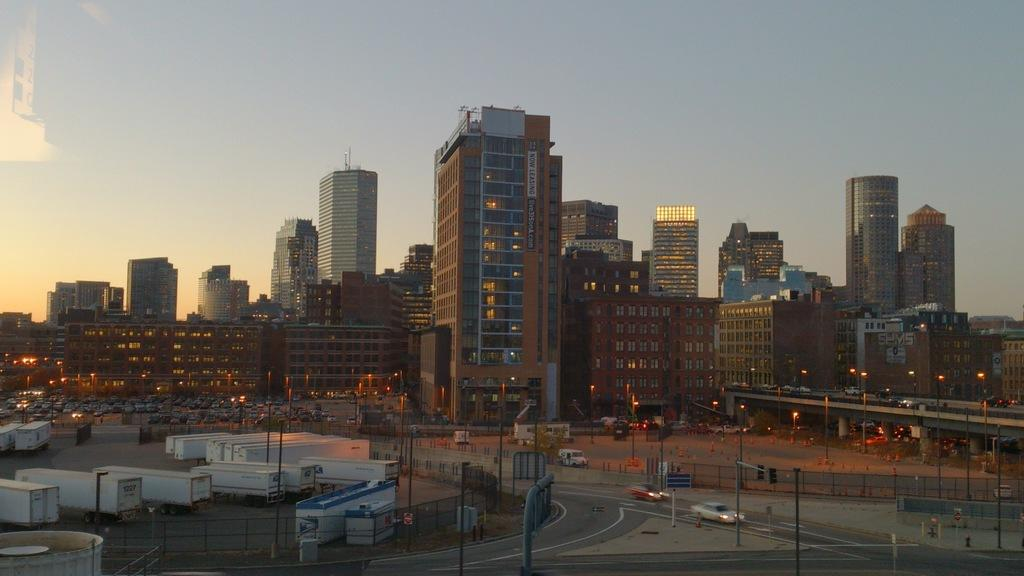What is the main subject of the image? The main subject of the image is many vehicles. Are there any structures or objects surrounding the vehicles? Yes, there are poles and fencing around the vehicles. What can be seen on the right side of the image? There is a bridge on the right side of the image. What is visible behind the bridge? There are plenty of buildings behind the bridge. What type of comb is used to adjust the acoustics in the image? There is no comb or mention of acoustics in the image; it primarily features vehicles, poles, fencing, a bridge, and buildings. 